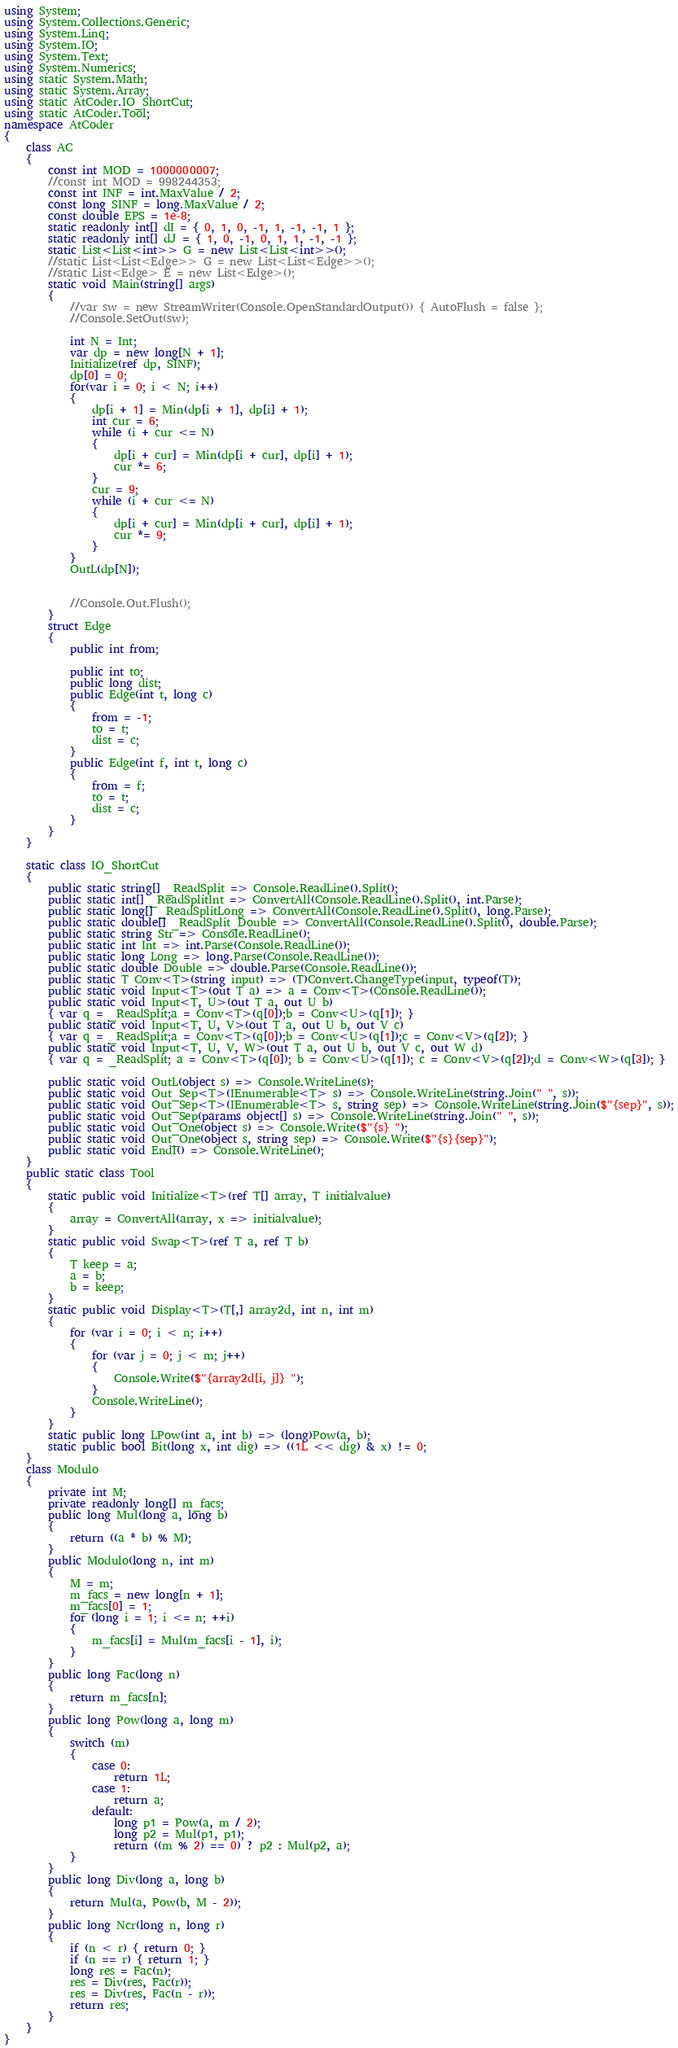Convert code to text. <code><loc_0><loc_0><loc_500><loc_500><_C#_>using System;
using System.Collections.Generic;
using System.Linq;
using System.IO;
using System.Text;
using System.Numerics;
using static System.Math;
using static System.Array;
using static AtCoder.IO_ShortCut;
using static AtCoder.Tool;
namespace AtCoder
{
    class AC
    {
        const int MOD = 1000000007;
        //const int MOD = 998244353;
        const int INF = int.MaxValue / 2;
        const long SINF = long.MaxValue / 2;
        const double EPS = 1e-8;
        static readonly int[] dI = { 0, 1, 0, -1, 1, -1, -1, 1 };
        static readonly int[] dJ = { 1, 0, -1, 0, 1, 1, -1, -1 };
        static List<List<int>> G = new List<List<int>>();
        //static List<List<Edge>> G = new List<List<Edge>>();
        //static List<Edge> E = new List<Edge>();
        static void Main(string[] args)
        {
            //var sw = new StreamWriter(Console.OpenStandardOutput()) { AutoFlush = false };
            //Console.SetOut(sw);

            int N = Int;
            var dp = new long[N + 1];
            Initialize(ref dp, SINF);
            dp[0] = 0;
            for(var i = 0; i < N; i++)
            {
                dp[i + 1] = Min(dp[i + 1], dp[i] + 1);
                int cur = 6;
                while (i + cur <= N)
                {
                    dp[i + cur] = Min(dp[i + cur], dp[i] + 1);
                    cur *= 6;
                }
                cur = 9;
                while (i + cur <= N)
                {
                    dp[i + cur] = Min(dp[i + cur], dp[i] + 1);
                    cur *= 9;
                }
            }
            OutL(dp[N]);


            //Console.Out.Flush();
        }
        struct Edge
        {
            public int from;

            public int to;
            public long dist;
            public Edge(int t, long c)
            {
                from = -1;
                to = t;
                dist = c;
            }
            public Edge(int f, int t, long c)
            {
                from = f;
                to = t;
                dist = c;
            }
        }
    }
    
    static class IO_ShortCut
    {
        public static string[] _ReadSplit => Console.ReadLine().Split();
        public static int[] _ReadSplitInt => ConvertAll(Console.ReadLine().Split(), int.Parse);
        public static long[] _ReadSplitLong => ConvertAll(Console.ReadLine().Split(), long.Parse);
        public static double[] _ReadSplit_Double => ConvertAll(Console.ReadLine().Split(), double.Parse);
        public static string Str => Console.ReadLine();
        public static int Int => int.Parse(Console.ReadLine());
        public static long Long => long.Parse(Console.ReadLine());
        public static double Double => double.Parse(Console.ReadLine());
        public static T Conv<T>(string input) => (T)Convert.ChangeType(input, typeof(T));
        public static void Input<T>(out T a) => a = Conv<T>(Console.ReadLine());
        public static void Input<T, U>(out T a, out U b)
        { var q = _ReadSplit;a = Conv<T>(q[0]);b = Conv<U>(q[1]); }
        public static void Input<T, U, V>(out T a, out U b, out V c)
        { var q = _ReadSplit;a = Conv<T>(q[0]);b = Conv<U>(q[1]);c = Conv<V>(q[2]); }
        public static void Input<T, U, V, W>(out T a, out U b, out V c, out W d)
        { var q = _ReadSplit; a = Conv<T>(q[0]); b = Conv<U>(q[1]); c = Conv<V>(q[2]);d = Conv<W>(q[3]); }

        public static void OutL(object s) => Console.WriteLine(s);
        public static void Out_Sep<T>(IEnumerable<T> s) => Console.WriteLine(string.Join(" ", s));
        public static void Out_Sep<T>(IEnumerable<T> s, string sep) => Console.WriteLine(string.Join($"{sep}", s));
        public static void Out_Sep(params object[] s) => Console.WriteLine(string.Join(" ", s));
        public static void Out_One(object s) => Console.Write($"{s} ");
        public static void Out_One(object s, string sep) => Console.Write($"{s}{sep}");
        public static void Endl() => Console.WriteLine();
    }
    public static class Tool
    {
        static public void Initialize<T>(ref T[] array, T initialvalue)
        {
            array = ConvertAll(array, x => initialvalue);
        }
        static public void Swap<T>(ref T a, ref T b)
        {
            T keep = a;
            a = b;
            b = keep;
        }
        static public void Display<T>(T[,] array2d, int n, int m)
        {
            for (var i = 0; i < n; i++)
            {
                for (var j = 0; j < m; j++)
                {
                    Console.Write($"{array2d[i, j]} ");
                }
                Console.WriteLine();
            }
        }
        static public long LPow(int a, int b) => (long)Pow(a, b);
        static public bool Bit(long x, int dig) => ((1L << dig) & x) != 0;
    }
    class Modulo
    {
        private int M;
        private readonly long[] m_facs;
        public long Mul(long a, long b)
        {
            return ((a * b) % M);
        }
        public Modulo(long n, int m)
        {
            M = m;
            m_facs = new long[n + 1];
            m_facs[0] = 1;
            for (long i = 1; i <= n; ++i)
            {
                m_facs[i] = Mul(m_facs[i - 1], i);
            }
        }
        public long Fac(long n)
        {
            return m_facs[n];
        }
        public long Pow(long a, long m)
        {
            switch (m)
            {
                case 0:
                    return 1L;
                case 1:
                    return a;
                default:
                    long p1 = Pow(a, m / 2);
                    long p2 = Mul(p1, p1);
                    return ((m % 2) == 0) ? p2 : Mul(p2, a);
            }
        }
        public long Div(long a, long b)
        {
            return Mul(a, Pow(b, M - 2));
        }
        public long Ncr(long n, long r)
        {
            if (n < r) { return 0; }
            if (n == r) { return 1; }
            long res = Fac(n);
            res = Div(res, Fac(r));
            res = Div(res, Fac(n - r));
            return res;
        }
    }
}
</code> 